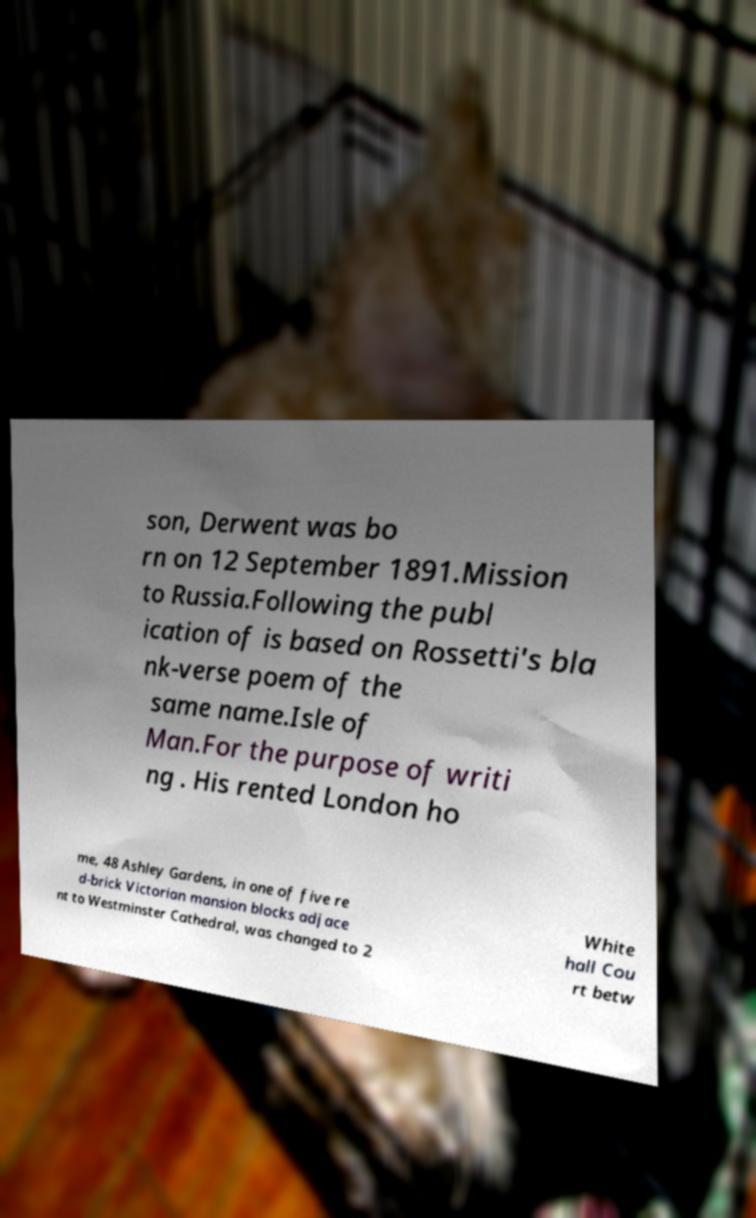Can you accurately transcribe the text from the provided image for me? son, Derwent was bo rn on 12 September 1891.Mission to Russia.Following the publ ication of is based on Rossetti's bla nk-verse poem of the same name.Isle of Man.For the purpose of writi ng . His rented London ho me, 48 Ashley Gardens, in one of five re d-brick Victorian mansion blocks adjace nt to Westminster Cathedral, was changed to 2 White hall Cou rt betw 